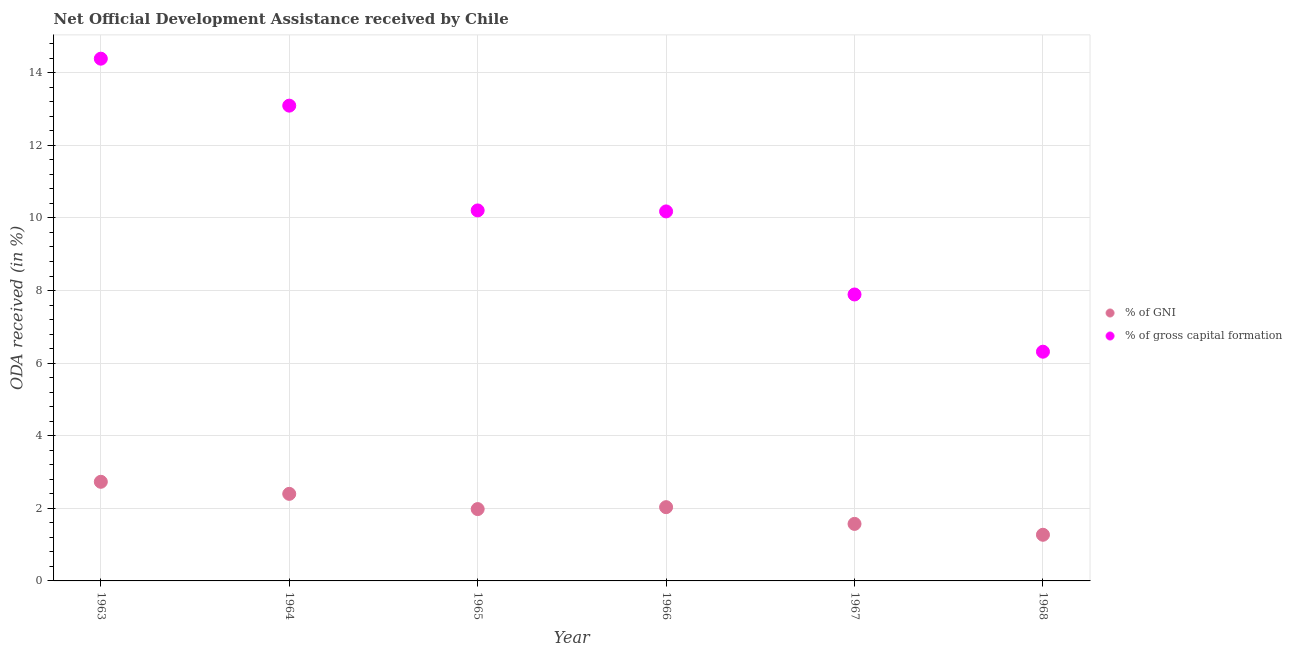How many different coloured dotlines are there?
Provide a succinct answer. 2. Is the number of dotlines equal to the number of legend labels?
Provide a succinct answer. Yes. What is the oda received as percentage of gross capital formation in 1967?
Keep it short and to the point. 7.89. Across all years, what is the maximum oda received as percentage of gni?
Keep it short and to the point. 2.73. Across all years, what is the minimum oda received as percentage of gross capital formation?
Keep it short and to the point. 6.32. In which year was the oda received as percentage of gross capital formation minimum?
Offer a terse response. 1968. What is the total oda received as percentage of gni in the graph?
Provide a succinct answer. 11.98. What is the difference between the oda received as percentage of gni in 1964 and that in 1967?
Ensure brevity in your answer.  0.83. What is the difference between the oda received as percentage of gross capital formation in 1963 and the oda received as percentage of gni in 1965?
Ensure brevity in your answer.  12.41. What is the average oda received as percentage of gross capital formation per year?
Your response must be concise. 10.35. In the year 1963, what is the difference between the oda received as percentage of gross capital formation and oda received as percentage of gni?
Keep it short and to the point. 11.66. In how many years, is the oda received as percentage of gross capital formation greater than 13.6 %?
Give a very brief answer. 1. What is the ratio of the oda received as percentage of gni in 1964 to that in 1968?
Your response must be concise. 1.89. Is the oda received as percentage of gni in 1964 less than that in 1965?
Offer a very short reply. No. Is the difference between the oda received as percentage of gni in 1967 and 1968 greater than the difference between the oda received as percentage of gross capital formation in 1967 and 1968?
Give a very brief answer. No. What is the difference between the highest and the second highest oda received as percentage of gni?
Provide a short and direct response. 0.33. What is the difference between the highest and the lowest oda received as percentage of gni?
Give a very brief answer. 1.46. In how many years, is the oda received as percentage of gni greater than the average oda received as percentage of gni taken over all years?
Provide a short and direct response. 3. How many dotlines are there?
Offer a terse response. 2. How many years are there in the graph?
Make the answer very short. 6. What is the difference between two consecutive major ticks on the Y-axis?
Ensure brevity in your answer.  2. Does the graph contain grids?
Offer a very short reply. Yes. How many legend labels are there?
Offer a terse response. 2. What is the title of the graph?
Offer a terse response. Net Official Development Assistance received by Chile. Does "Non-residents" appear as one of the legend labels in the graph?
Your response must be concise. No. What is the label or title of the Y-axis?
Keep it short and to the point. ODA received (in %). What is the ODA received (in %) in % of GNI in 1963?
Provide a succinct answer. 2.73. What is the ODA received (in %) in % of gross capital formation in 1963?
Offer a very short reply. 14.39. What is the ODA received (in %) of % of GNI in 1964?
Keep it short and to the point. 2.4. What is the ODA received (in %) in % of gross capital formation in 1964?
Ensure brevity in your answer.  13.09. What is the ODA received (in %) of % of GNI in 1965?
Your answer should be compact. 1.98. What is the ODA received (in %) in % of gross capital formation in 1965?
Give a very brief answer. 10.21. What is the ODA received (in %) of % of GNI in 1966?
Ensure brevity in your answer.  2.03. What is the ODA received (in %) in % of gross capital formation in 1966?
Give a very brief answer. 10.18. What is the ODA received (in %) of % of GNI in 1967?
Offer a very short reply. 1.57. What is the ODA received (in %) of % of gross capital formation in 1967?
Offer a very short reply. 7.89. What is the ODA received (in %) of % of GNI in 1968?
Offer a terse response. 1.27. What is the ODA received (in %) of % of gross capital formation in 1968?
Offer a very short reply. 6.32. Across all years, what is the maximum ODA received (in %) in % of GNI?
Your answer should be compact. 2.73. Across all years, what is the maximum ODA received (in %) in % of gross capital formation?
Your answer should be very brief. 14.39. Across all years, what is the minimum ODA received (in %) in % of GNI?
Give a very brief answer. 1.27. Across all years, what is the minimum ODA received (in %) in % of gross capital formation?
Ensure brevity in your answer.  6.32. What is the total ODA received (in %) in % of GNI in the graph?
Provide a short and direct response. 11.98. What is the total ODA received (in %) of % of gross capital formation in the graph?
Give a very brief answer. 62.08. What is the difference between the ODA received (in %) in % of GNI in 1963 and that in 1964?
Your answer should be very brief. 0.33. What is the difference between the ODA received (in %) in % of gross capital formation in 1963 and that in 1964?
Ensure brevity in your answer.  1.29. What is the difference between the ODA received (in %) of % of GNI in 1963 and that in 1965?
Your response must be concise. 0.75. What is the difference between the ODA received (in %) in % of gross capital formation in 1963 and that in 1965?
Your answer should be compact. 4.18. What is the difference between the ODA received (in %) in % of GNI in 1963 and that in 1966?
Make the answer very short. 0.7. What is the difference between the ODA received (in %) in % of gross capital formation in 1963 and that in 1966?
Provide a succinct answer. 4.21. What is the difference between the ODA received (in %) in % of GNI in 1963 and that in 1967?
Give a very brief answer. 1.16. What is the difference between the ODA received (in %) in % of gross capital formation in 1963 and that in 1967?
Your answer should be compact. 6.5. What is the difference between the ODA received (in %) in % of GNI in 1963 and that in 1968?
Give a very brief answer. 1.46. What is the difference between the ODA received (in %) in % of gross capital formation in 1963 and that in 1968?
Provide a succinct answer. 8.07. What is the difference between the ODA received (in %) of % of GNI in 1964 and that in 1965?
Your answer should be very brief. 0.42. What is the difference between the ODA received (in %) in % of gross capital formation in 1964 and that in 1965?
Ensure brevity in your answer.  2.89. What is the difference between the ODA received (in %) of % of GNI in 1964 and that in 1966?
Provide a short and direct response. 0.37. What is the difference between the ODA received (in %) of % of gross capital formation in 1964 and that in 1966?
Ensure brevity in your answer.  2.91. What is the difference between the ODA received (in %) in % of GNI in 1964 and that in 1967?
Your answer should be compact. 0.83. What is the difference between the ODA received (in %) in % of gross capital formation in 1964 and that in 1967?
Your answer should be compact. 5.2. What is the difference between the ODA received (in %) in % of GNI in 1964 and that in 1968?
Offer a very short reply. 1.13. What is the difference between the ODA received (in %) of % of gross capital formation in 1964 and that in 1968?
Your answer should be very brief. 6.78. What is the difference between the ODA received (in %) in % of GNI in 1965 and that in 1966?
Offer a terse response. -0.05. What is the difference between the ODA received (in %) of % of gross capital formation in 1965 and that in 1966?
Offer a terse response. 0.03. What is the difference between the ODA received (in %) of % of GNI in 1965 and that in 1967?
Your response must be concise. 0.41. What is the difference between the ODA received (in %) of % of gross capital formation in 1965 and that in 1967?
Ensure brevity in your answer.  2.32. What is the difference between the ODA received (in %) in % of GNI in 1965 and that in 1968?
Offer a terse response. 0.71. What is the difference between the ODA received (in %) of % of gross capital formation in 1965 and that in 1968?
Provide a succinct answer. 3.89. What is the difference between the ODA received (in %) of % of GNI in 1966 and that in 1967?
Provide a short and direct response. 0.46. What is the difference between the ODA received (in %) of % of gross capital formation in 1966 and that in 1967?
Your answer should be very brief. 2.29. What is the difference between the ODA received (in %) in % of GNI in 1966 and that in 1968?
Your answer should be very brief. 0.76. What is the difference between the ODA received (in %) of % of gross capital formation in 1966 and that in 1968?
Ensure brevity in your answer.  3.86. What is the difference between the ODA received (in %) in % of GNI in 1967 and that in 1968?
Your answer should be very brief. 0.3. What is the difference between the ODA received (in %) in % of gross capital formation in 1967 and that in 1968?
Provide a short and direct response. 1.58. What is the difference between the ODA received (in %) in % of GNI in 1963 and the ODA received (in %) in % of gross capital formation in 1964?
Keep it short and to the point. -10.36. What is the difference between the ODA received (in %) of % of GNI in 1963 and the ODA received (in %) of % of gross capital formation in 1965?
Provide a short and direct response. -7.48. What is the difference between the ODA received (in %) of % of GNI in 1963 and the ODA received (in %) of % of gross capital formation in 1966?
Your response must be concise. -7.45. What is the difference between the ODA received (in %) in % of GNI in 1963 and the ODA received (in %) in % of gross capital formation in 1967?
Offer a terse response. -5.16. What is the difference between the ODA received (in %) in % of GNI in 1963 and the ODA received (in %) in % of gross capital formation in 1968?
Give a very brief answer. -3.58. What is the difference between the ODA received (in %) of % of GNI in 1964 and the ODA received (in %) of % of gross capital formation in 1965?
Provide a short and direct response. -7.81. What is the difference between the ODA received (in %) of % of GNI in 1964 and the ODA received (in %) of % of gross capital formation in 1966?
Your response must be concise. -7.78. What is the difference between the ODA received (in %) in % of GNI in 1964 and the ODA received (in %) in % of gross capital formation in 1967?
Make the answer very short. -5.49. What is the difference between the ODA received (in %) in % of GNI in 1964 and the ODA received (in %) in % of gross capital formation in 1968?
Your answer should be compact. -3.92. What is the difference between the ODA received (in %) in % of GNI in 1965 and the ODA received (in %) in % of gross capital formation in 1966?
Your response must be concise. -8.2. What is the difference between the ODA received (in %) in % of GNI in 1965 and the ODA received (in %) in % of gross capital formation in 1967?
Give a very brief answer. -5.91. What is the difference between the ODA received (in %) of % of GNI in 1965 and the ODA received (in %) of % of gross capital formation in 1968?
Your response must be concise. -4.34. What is the difference between the ODA received (in %) of % of GNI in 1966 and the ODA received (in %) of % of gross capital formation in 1967?
Provide a succinct answer. -5.86. What is the difference between the ODA received (in %) in % of GNI in 1966 and the ODA received (in %) in % of gross capital formation in 1968?
Ensure brevity in your answer.  -4.28. What is the difference between the ODA received (in %) of % of GNI in 1967 and the ODA received (in %) of % of gross capital formation in 1968?
Your answer should be compact. -4.74. What is the average ODA received (in %) of % of GNI per year?
Give a very brief answer. 2. What is the average ODA received (in %) in % of gross capital formation per year?
Your response must be concise. 10.35. In the year 1963, what is the difference between the ODA received (in %) in % of GNI and ODA received (in %) in % of gross capital formation?
Ensure brevity in your answer.  -11.66. In the year 1964, what is the difference between the ODA received (in %) of % of GNI and ODA received (in %) of % of gross capital formation?
Ensure brevity in your answer.  -10.7. In the year 1965, what is the difference between the ODA received (in %) in % of GNI and ODA received (in %) in % of gross capital formation?
Provide a succinct answer. -8.23. In the year 1966, what is the difference between the ODA received (in %) in % of GNI and ODA received (in %) in % of gross capital formation?
Give a very brief answer. -8.15. In the year 1967, what is the difference between the ODA received (in %) in % of GNI and ODA received (in %) in % of gross capital formation?
Make the answer very short. -6.32. In the year 1968, what is the difference between the ODA received (in %) in % of GNI and ODA received (in %) in % of gross capital formation?
Offer a very short reply. -5.04. What is the ratio of the ODA received (in %) of % of GNI in 1963 to that in 1964?
Offer a very short reply. 1.14. What is the ratio of the ODA received (in %) of % of gross capital formation in 1963 to that in 1964?
Your response must be concise. 1.1. What is the ratio of the ODA received (in %) of % of GNI in 1963 to that in 1965?
Offer a very short reply. 1.38. What is the ratio of the ODA received (in %) of % of gross capital formation in 1963 to that in 1965?
Your response must be concise. 1.41. What is the ratio of the ODA received (in %) in % of GNI in 1963 to that in 1966?
Make the answer very short. 1.34. What is the ratio of the ODA received (in %) of % of gross capital formation in 1963 to that in 1966?
Ensure brevity in your answer.  1.41. What is the ratio of the ODA received (in %) of % of GNI in 1963 to that in 1967?
Provide a succinct answer. 1.74. What is the ratio of the ODA received (in %) in % of gross capital formation in 1963 to that in 1967?
Keep it short and to the point. 1.82. What is the ratio of the ODA received (in %) in % of GNI in 1963 to that in 1968?
Your answer should be compact. 2.15. What is the ratio of the ODA received (in %) in % of gross capital formation in 1963 to that in 1968?
Ensure brevity in your answer.  2.28. What is the ratio of the ODA received (in %) in % of GNI in 1964 to that in 1965?
Offer a terse response. 1.21. What is the ratio of the ODA received (in %) of % of gross capital formation in 1964 to that in 1965?
Ensure brevity in your answer.  1.28. What is the ratio of the ODA received (in %) of % of GNI in 1964 to that in 1966?
Offer a very short reply. 1.18. What is the ratio of the ODA received (in %) in % of gross capital formation in 1964 to that in 1966?
Provide a short and direct response. 1.29. What is the ratio of the ODA received (in %) of % of GNI in 1964 to that in 1967?
Offer a very short reply. 1.53. What is the ratio of the ODA received (in %) in % of gross capital formation in 1964 to that in 1967?
Give a very brief answer. 1.66. What is the ratio of the ODA received (in %) in % of GNI in 1964 to that in 1968?
Your response must be concise. 1.89. What is the ratio of the ODA received (in %) of % of gross capital formation in 1964 to that in 1968?
Your answer should be compact. 2.07. What is the ratio of the ODA received (in %) in % of GNI in 1965 to that in 1966?
Offer a very short reply. 0.97. What is the ratio of the ODA received (in %) of % of gross capital formation in 1965 to that in 1966?
Your response must be concise. 1. What is the ratio of the ODA received (in %) in % of GNI in 1965 to that in 1967?
Your answer should be compact. 1.26. What is the ratio of the ODA received (in %) in % of gross capital formation in 1965 to that in 1967?
Your answer should be compact. 1.29. What is the ratio of the ODA received (in %) in % of GNI in 1965 to that in 1968?
Offer a terse response. 1.56. What is the ratio of the ODA received (in %) of % of gross capital formation in 1965 to that in 1968?
Provide a short and direct response. 1.62. What is the ratio of the ODA received (in %) of % of GNI in 1966 to that in 1967?
Give a very brief answer. 1.29. What is the ratio of the ODA received (in %) of % of gross capital formation in 1966 to that in 1967?
Keep it short and to the point. 1.29. What is the ratio of the ODA received (in %) of % of GNI in 1966 to that in 1968?
Provide a succinct answer. 1.6. What is the ratio of the ODA received (in %) of % of gross capital formation in 1966 to that in 1968?
Your answer should be compact. 1.61. What is the ratio of the ODA received (in %) in % of GNI in 1967 to that in 1968?
Ensure brevity in your answer.  1.24. What is the ratio of the ODA received (in %) of % of gross capital formation in 1967 to that in 1968?
Provide a succinct answer. 1.25. What is the difference between the highest and the second highest ODA received (in %) in % of GNI?
Give a very brief answer. 0.33. What is the difference between the highest and the second highest ODA received (in %) of % of gross capital formation?
Provide a succinct answer. 1.29. What is the difference between the highest and the lowest ODA received (in %) in % of GNI?
Give a very brief answer. 1.46. What is the difference between the highest and the lowest ODA received (in %) in % of gross capital formation?
Give a very brief answer. 8.07. 